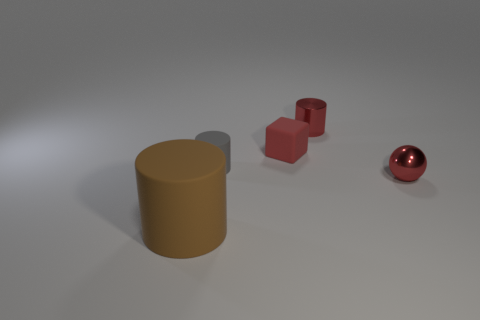Can you describe the shapes and their arrangement in the image? Certainly! In the image, there are three primary shapes arranged from left to right. On the left, there is a pair of connected cubes, one slightly elevated above the other, both with a matte red finish. At the center, there's a mustard yellow cylinder standing upright. Finally, to the right, there is a sphere with a reflective surface that seems to be casting a soft shadow on the ground. 